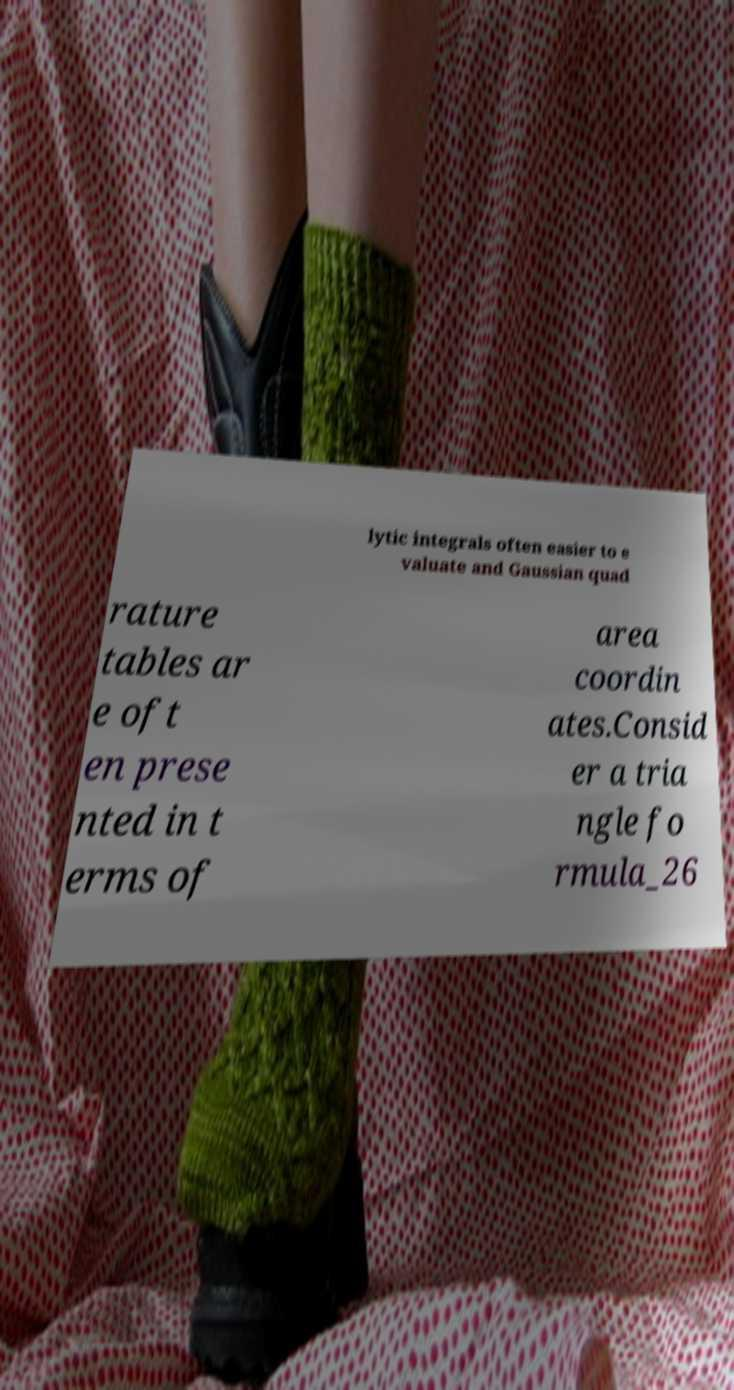Could you extract and type out the text from this image? lytic integrals often easier to e valuate and Gaussian quad rature tables ar e oft en prese nted in t erms of area coordin ates.Consid er a tria ngle fo rmula_26 